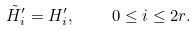Convert formula to latex. <formula><loc_0><loc_0><loc_500><loc_500>\tilde { H } ^ { \prime } _ { i } = H ^ { \prime } _ { i } , \quad 0 \leq i \leq 2 r .</formula> 